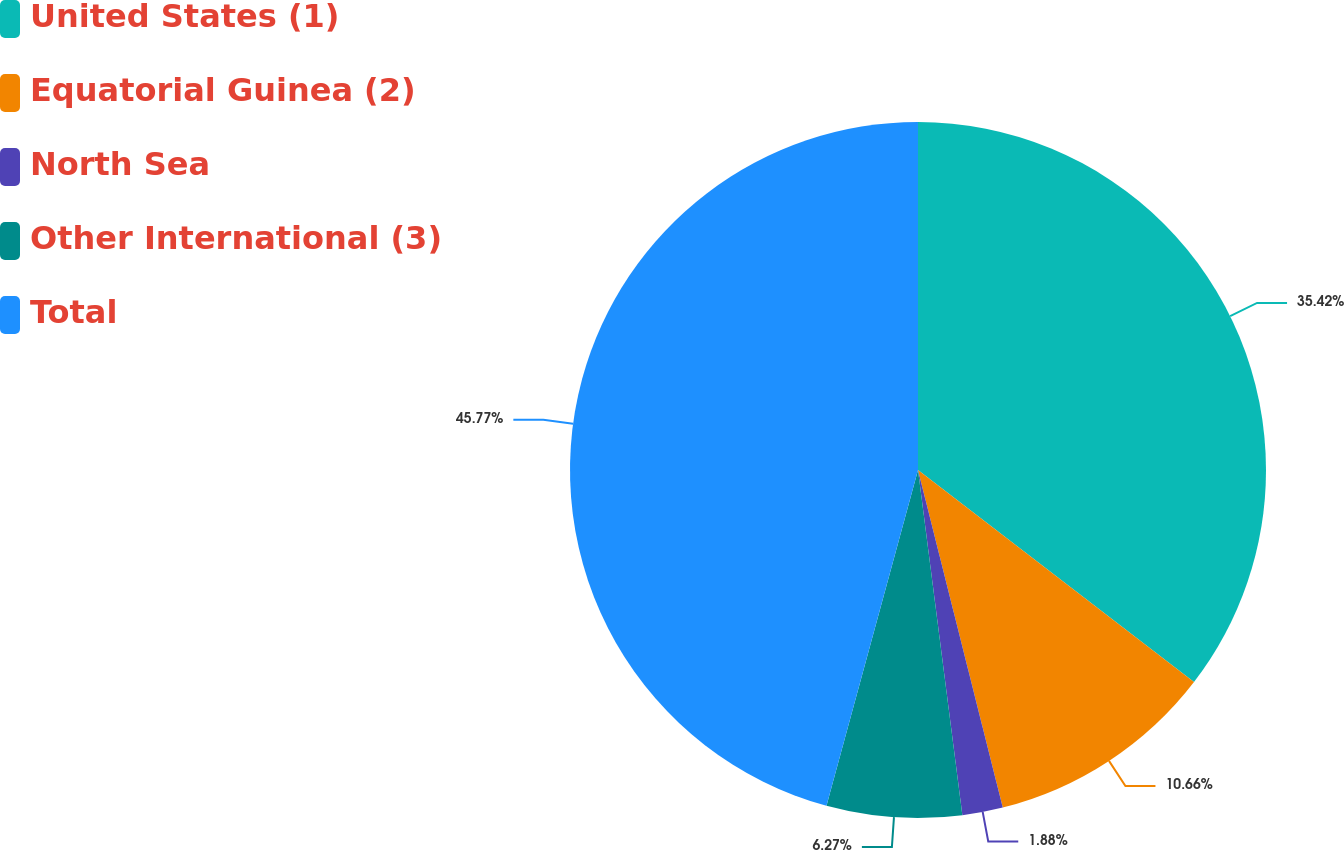Convert chart to OTSL. <chart><loc_0><loc_0><loc_500><loc_500><pie_chart><fcel>United States (1)<fcel>Equatorial Guinea (2)<fcel>North Sea<fcel>Other International (3)<fcel>Total<nl><fcel>35.42%<fcel>10.66%<fcel>1.88%<fcel>6.27%<fcel>45.76%<nl></chart> 